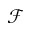<formula> <loc_0><loc_0><loc_500><loc_500>\mathcal { F }</formula> 